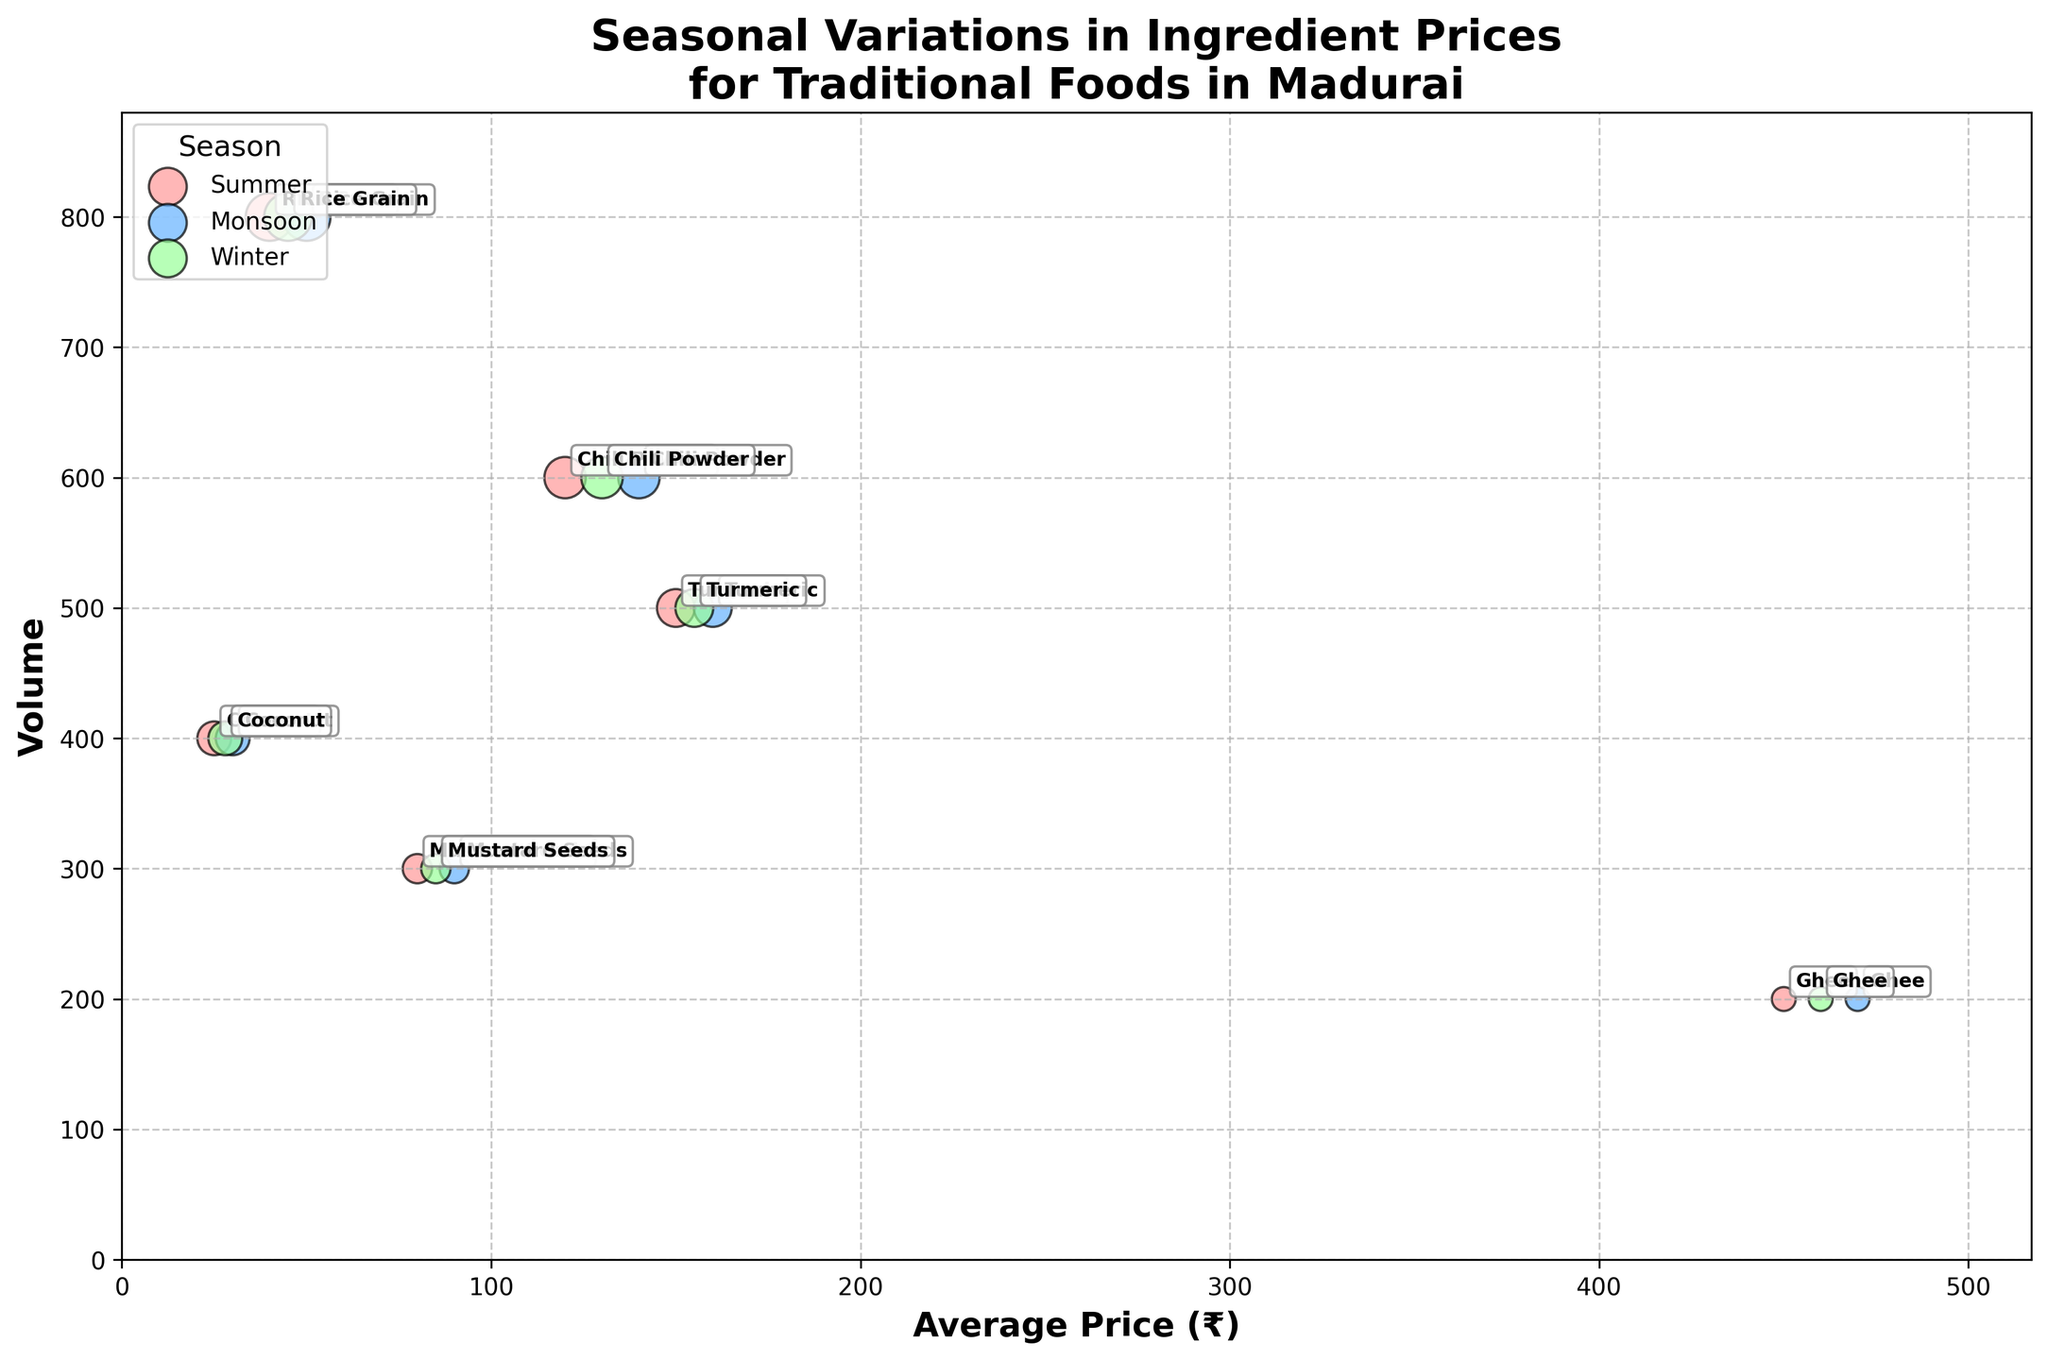what is the average price range of ingredients in the figure? The average price (₹) ranges from the minimum value on the x-axis to the maximum value. The lowest average price is 25 (Coconut in Summer) and the highest is 470 (Ghee in Monsoon).
Answer: 25 to 470 Which season do most ingredients see a price increase? By comparing the positions of the bubbles across seasons, it is apparent that many ingredients have higher prices in Monsoon as their bubbles shift right compared to Summer and Winter.
Answer: Monsoon What is the volume range of ingredients shown in the figure? The volume ranges from the smallest value on the y-axis to the largest. The lowest volume is 200 (Ghee in all seasons), and the highest is 800 (Rice Grain in all seasons).
Answer: 200 to 800 Which ingredient has the most consistent (least changing) price across the seasons? Look for the ingredient with bubbles closest together along the x-axis. Rice Grain has prices ranging narrowly from 40 to 50.
Answer: Rice Grain Among Chili Powder and Coconut, which has a larger volume in all seasons? Compare the y-axis positions of Chili Powder and Coconut. Chili Powder is always at 600, while Coconut is always at 400. Thus, Chili Powder has a larger volume.
Answer: Chili Powder Which ingredient has an average price closest to 150 during Summer? Look on the x-axis for bubbles around 150 under the label 'Summer'. Turmeric has an average price of 150 in Summer.
Answer: Turmeric How many different ingredients are represented in the chart? Count the unique ingredient names annotated next to the bubbles. There are 6 different ingredients: Rice Grain, Chili Powder, Mustard Seeds, Turmeric, Coconut, Ghee.
Answer: 6 Which ingredient shows the smallest change in volume across different seasons? Check the bubbles' y-axis positions for different seasons. The volumes for all ingredients remain constant across seasons, but Ghee’s volume is consistently among the smallest, which might be easier to identify.
Answer: Ghee Which season has the highest average prices overall? By examining the x-axis positions of the bubbles, Monsoon season generally has higher prices than Summer and Winter as bubbles shift to the right.
Answer: Monsoon What is the average price of Coconut during Winter? Find the bubble for Coconut under 'Winter' and read its average price from the x-axis. The average price of Coconut in Winter is 28.
Answer: 28 